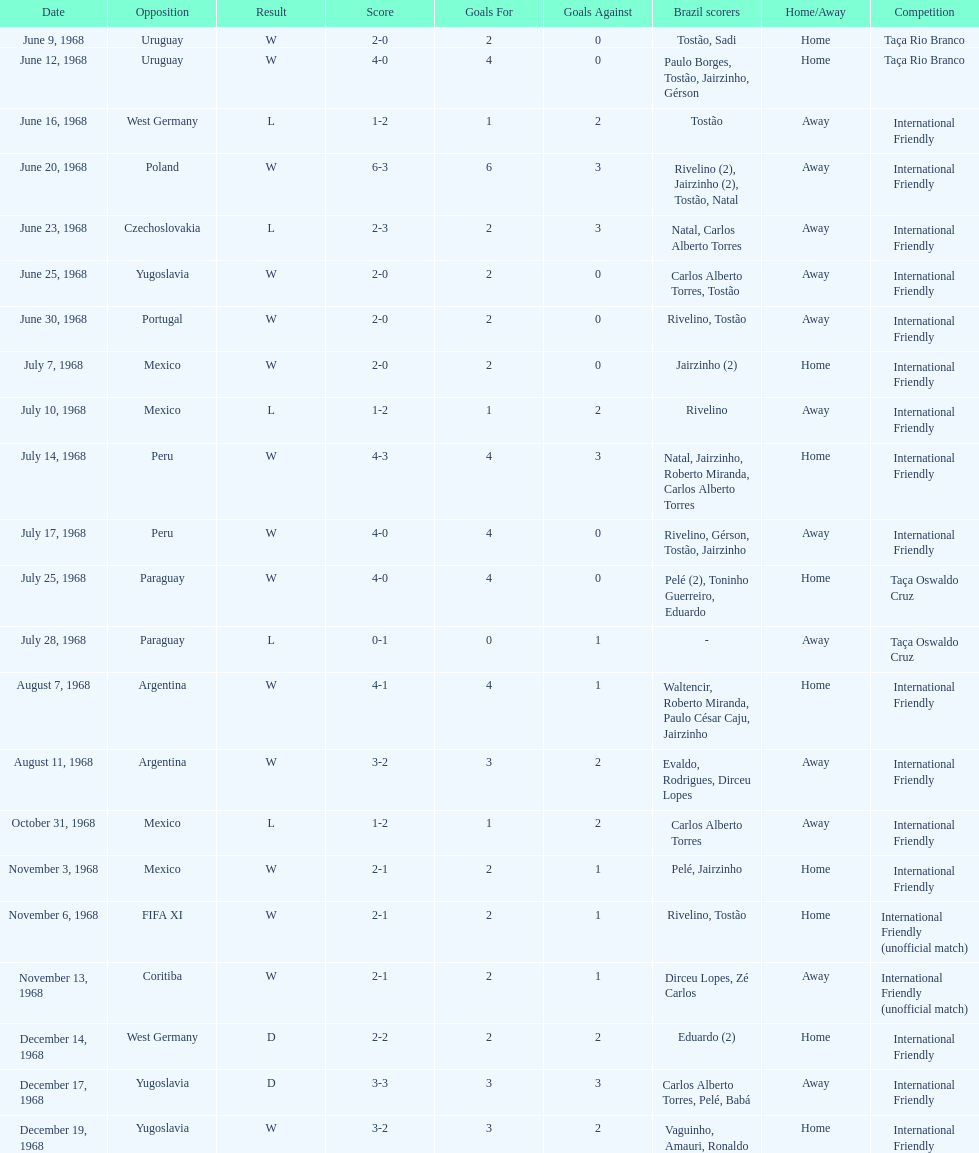Parse the full table. {'header': ['Date', 'Opposition', 'Result', 'Score', 'Goals For', 'Goals Against', 'Brazil scorers', 'Home/Away', 'Competition'], 'rows': [['June 9, 1968', 'Uruguay', 'W', '2-0', '2', '0', 'Tostão, Sadi', 'Home', 'Taça Rio Branco'], ['June 12, 1968', 'Uruguay', 'W', '4-0', '4', '0', 'Paulo Borges, Tostão, Jairzinho, Gérson', 'Home', 'Taça Rio Branco'], ['June 16, 1968', 'West Germany', 'L', '1-2', '1', '2', 'Tostão', 'Away', 'International Friendly'], ['June 20, 1968', 'Poland', 'W', '6-3', '6', '3', 'Rivelino (2), Jairzinho (2), Tostão, Natal', 'Away', 'International Friendly'], ['June 23, 1968', 'Czechoslovakia', 'L', '2-3', '2', '3', 'Natal, Carlos Alberto Torres', 'Away', 'International Friendly'], ['June 25, 1968', 'Yugoslavia', 'W', '2-0', '2', '0', 'Carlos Alberto Torres, Tostão', 'Away', 'International Friendly'], ['June 30, 1968', 'Portugal', 'W', '2-0', '2', '0', 'Rivelino, Tostão', 'Away', 'International Friendly'], ['July 7, 1968', 'Mexico', 'W', '2-0', '2', '0', 'Jairzinho (2)', 'Home', 'International Friendly'], ['July 10, 1968', 'Mexico', 'L', '1-2', '1', '2', 'Rivelino', 'Away', 'International Friendly'], ['July 14, 1968', 'Peru', 'W', '4-3', '4', '3', 'Natal, Jairzinho, Roberto Miranda, Carlos Alberto Torres', 'Home', 'International Friendly'], ['July 17, 1968', 'Peru', 'W', '4-0', '4', '0', 'Rivelino, Gérson, Tostão, Jairzinho', 'Away', 'International Friendly'], ['July 25, 1968', 'Paraguay', 'W', '4-0', '4', '0', 'Pelé (2), Toninho Guerreiro, Eduardo', 'Home', 'Taça Oswaldo Cruz'], ['July 28, 1968', 'Paraguay', 'L', '0-1', '0', '1', '-', 'Away', 'Taça Oswaldo Cruz'], ['August 7, 1968', 'Argentina', 'W', '4-1', '4', '1', 'Waltencir, Roberto Miranda, Paulo César Caju, Jairzinho', 'Home', 'International Friendly'], ['August 11, 1968', 'Argentina', 'W', '3-2', '3', '2', 'Evaldo, Rodrigues, Dirceu Lopes', 'Away', 'International Friendly'], ['October 31, 1968', 'Mexico', 'L', '1-2', '1', '2', 'Carlos Alberto Torres', 'Away', 'International Friendly'], ['November 3, 1968', 'Mexico', 'W', '2-1', '2', '1', 'Pelé, Jairzinho', 'Home', 'International Friendly'], ['November 6, 1968', 'FIFA XI', 'W', '2-1', '2', '1', 'Rivelino, Tostão', 'Home', 'International Friendly (unofficial match)'], ['November 13, 1968', 'Coritiba', 'W', '2-1', '2', '1', 'Dirceu Lopes, Zé Carlos', 'Away', 'International Friendly (unofficial match)'], ['December 14, 1968', 'West Germany', 'D', '2-2', '2', '2', 'Eduardo (2)', 'Home', 'International Friendly'], ['December 17, 1968', 'Yugoslavia', 'D', '3-3', '3', '3', 'Carlos Alberto Torres, Pelé, Babá', 'Away', 'International Friendly'], ['December 19, 1968', 'Yugoslavia', 'W', '3-2', '3', '2', 'Vaguinho, Amauri, Ronaldo', 'Home', 'International Friendly']]} Total number of wins 15. 